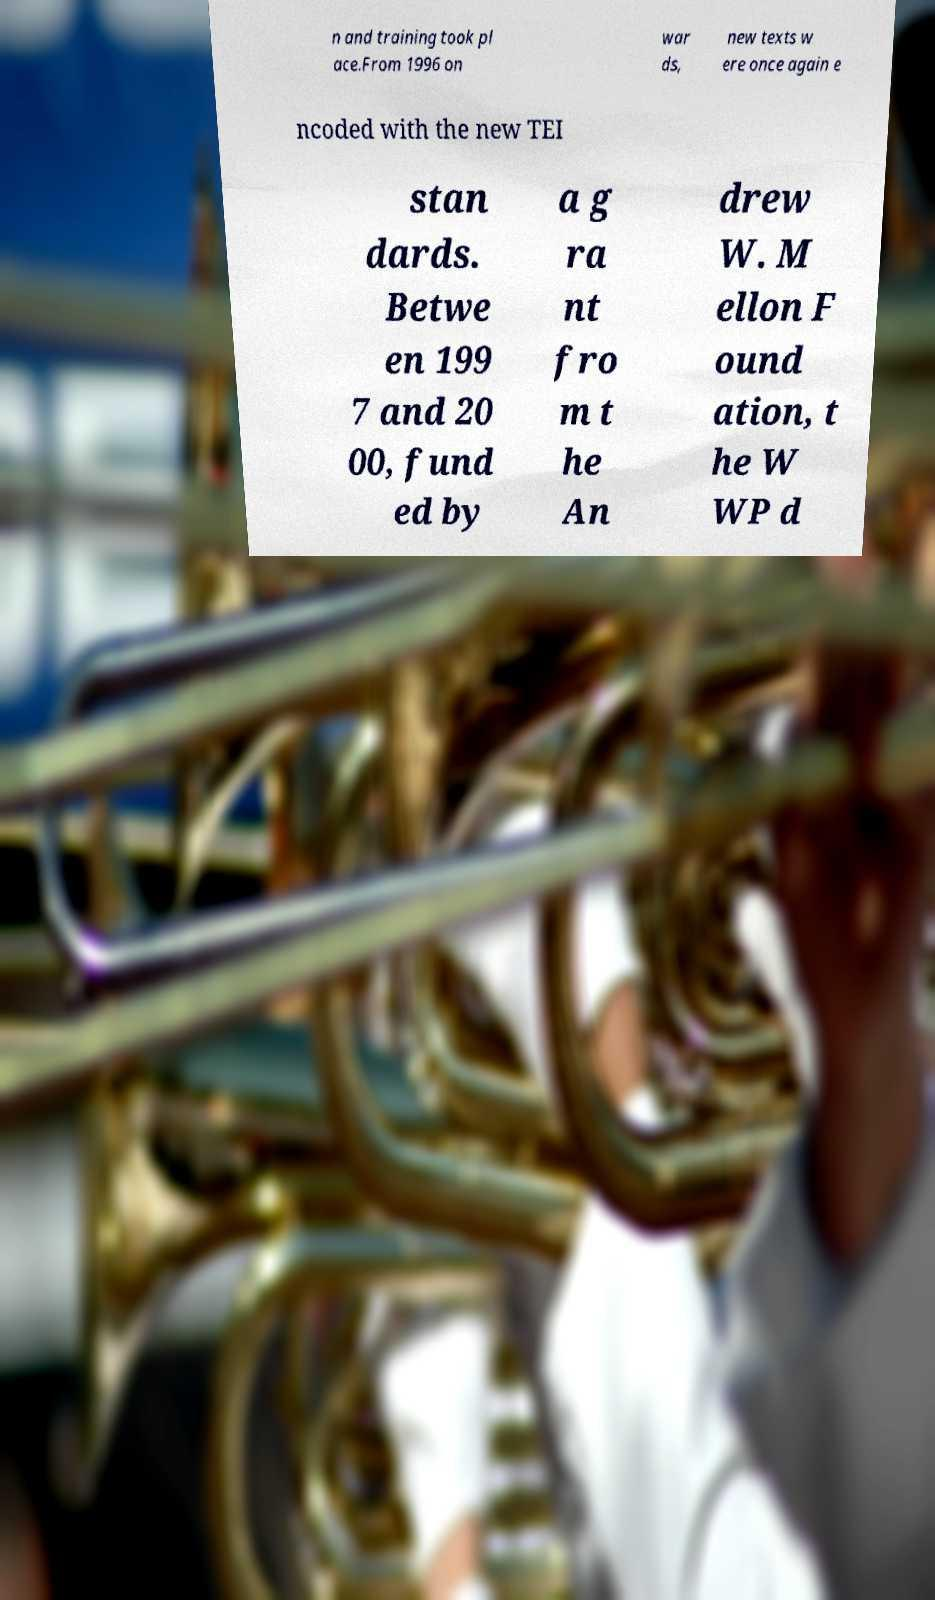Can you read and provide the text displayed in the image?This photo seems to have some interesting text. Can you extract and type it out for me? n and training took pl ace.From 1996 on war ds, new texts w ere once again e ncoded with the new TEI stan dards. Betwe en 199 7 and 20 00, fund ed by a g ra nt fro m t he An drew W. M ellon F ound ation, t he W WP d 